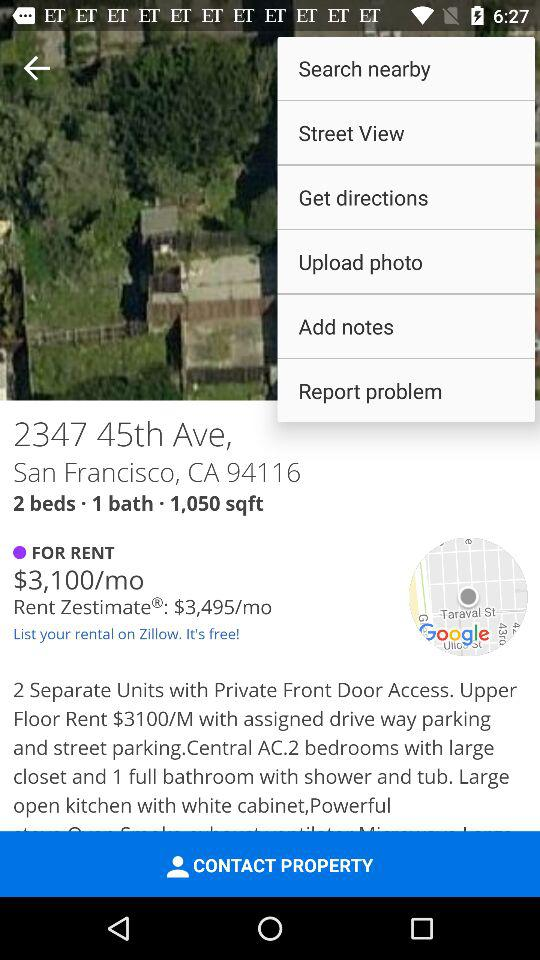How many bedrooms are available? There are 2 bedrooms available. 